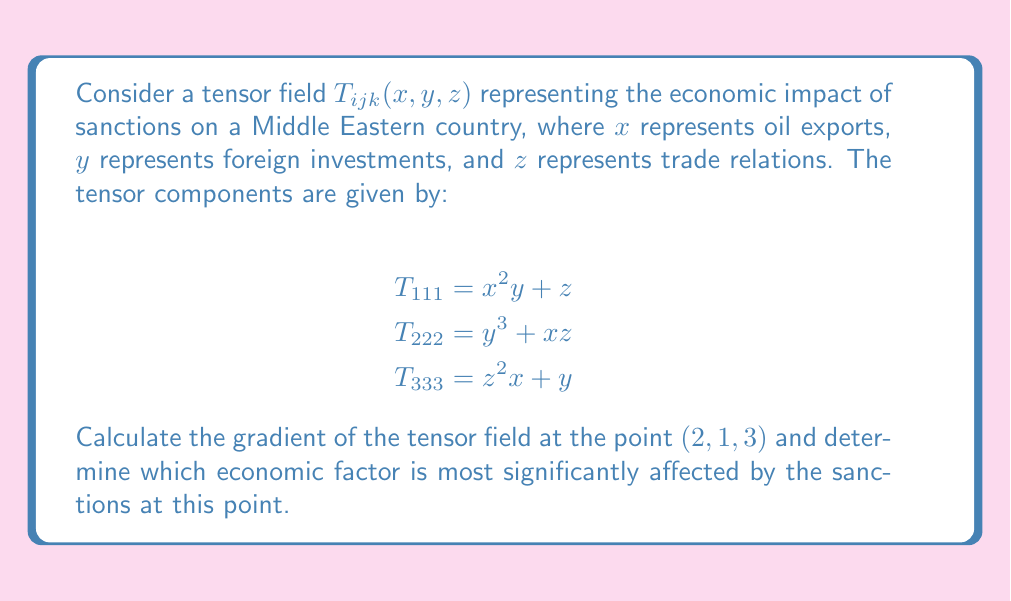Can you answer this question? To solve this problem, we need to follow these steps:

1) The gradient of a tensor field is a higher-order tensor. For a third-order tensor, the gradient is a fourth-order tensor given by:

   $$\nabla T_{ijk} = \frac{\partial T_{ijk}}{\partial x_l}$$

2) We need to calculate the partial derivatives with respect to $x$, $y$, and $z$ for each component:

   For $T_{111}$:
   $$\frac{\partial T_{111}}{\partial x} = 2xy$$
   $$\frac{\partial T_{111}}{\partial y} = x^2$$
   $$\frac{\partial T_{111}}{\partial z} = 1$$

   For $T_{222}$:
   $$\frac{\partial T_{222}}{\partial x} = z$$
   $$\frac{\partial T_{222}}{\partial y} = 3y^2$$
   $$\frac{\partial T_{222}}{\partial z} = x$$

   For $T_{333}$:
   $$\frac{\partial T_{333}}{\partial x} = z^2$$
   $$\frac{\partial T_{333}}{\partial y} = 1$$
   $$\frac{\partial T_{333}}{\partial z} = 2zx$$

3) Now, we evaluate these at the point $(2, 1, 3)$:

   $$\nabla T_{111} = (2(2)(1), 2^2, 1) = (4, 4, 1)$$
   $$\nabla T_{222} = (3, 3(1)^2, 2) = (3, 3, 2)$$
   $$\nabla T_{333} = (3^2, 1, 2(3)(2)) = (9, 1, 12)$$

4) To determine which economic factor is most significantly affected, we need to compare the magnitudes of these gradients:

   $$|\nabla T_{111}| = \sqrt{4^2 + 4^2 + 1^2} = \sqrt{33} \approx 5.74$$
   $$|\nabla T_{222}| = \sqrt{3^2 + 3^2 + 2^2} = \sqrt{22} \approx 4.69$$
   $$|\nabla T_{333}| = \sqrt{9^2 + 1^2 + 12^2} = \sqrt{226} \approx 15.03$$

5) The largest magnitude is $|\nabla T_{333}|$, which corresponds to the impact on trade relations ($z$).
Answer: Trade relations ($z$) are most significantly affected, with $|\nabla T_{333}| \approx 15.03$. 